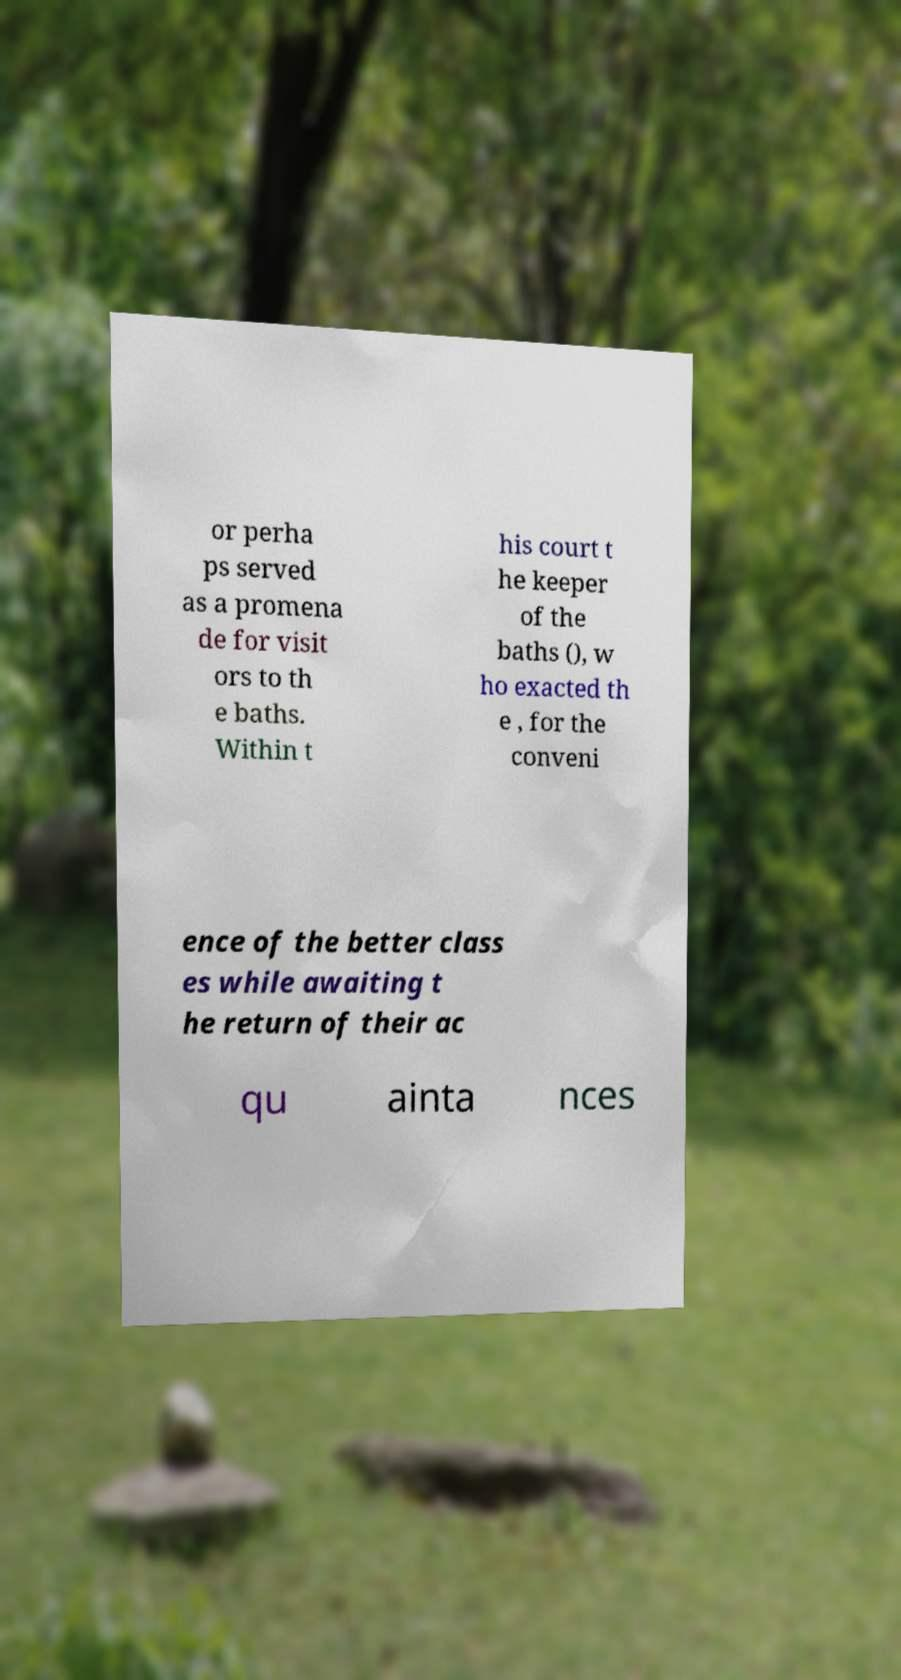Could you assist in decoding the text presented in this image and type it out clearly? or perha ps served as a promena de for visit ors to th e baths. Within t his court t he keeper of the baths (), w ho exacted th e , for the conveni ence of the better class es while awaiting t he return of their ac qu ainta nces 